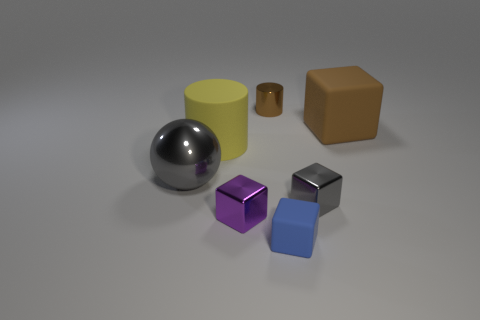Subtract all brown cubes. How many cubes are left? 3 Add 2 large rubber blocks. How many objects exist? 9 Subtract all blue blocks. How many blocks are left? 3 Subtract all spheres. How many objects are left? 6 Subtract all big cubes. Subtract all gray metallic blocks. How many objects are left? 5 Add 2 gray cubes. How many gray cubes are left? 3 Add 4 small blue rubber cubes. How many small blue rubber cubes exist? 5 Subtract 0 cyan cylinders. How many objects are left? 7 Subtract all green cylinders. Subtract all red blocks. How many cylinders are left? 2 